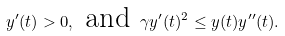Convert formula to latex. <formula><loc_0><loc_0><loc_500><loc_500>y ^ { \prime } ( t ) > 0 , \text { and } \gamma y ^ { \prime } ( t ) ^ { 2 } \leq y ( t ) y ^ { \prime \prime } ( t ) .</formula> 